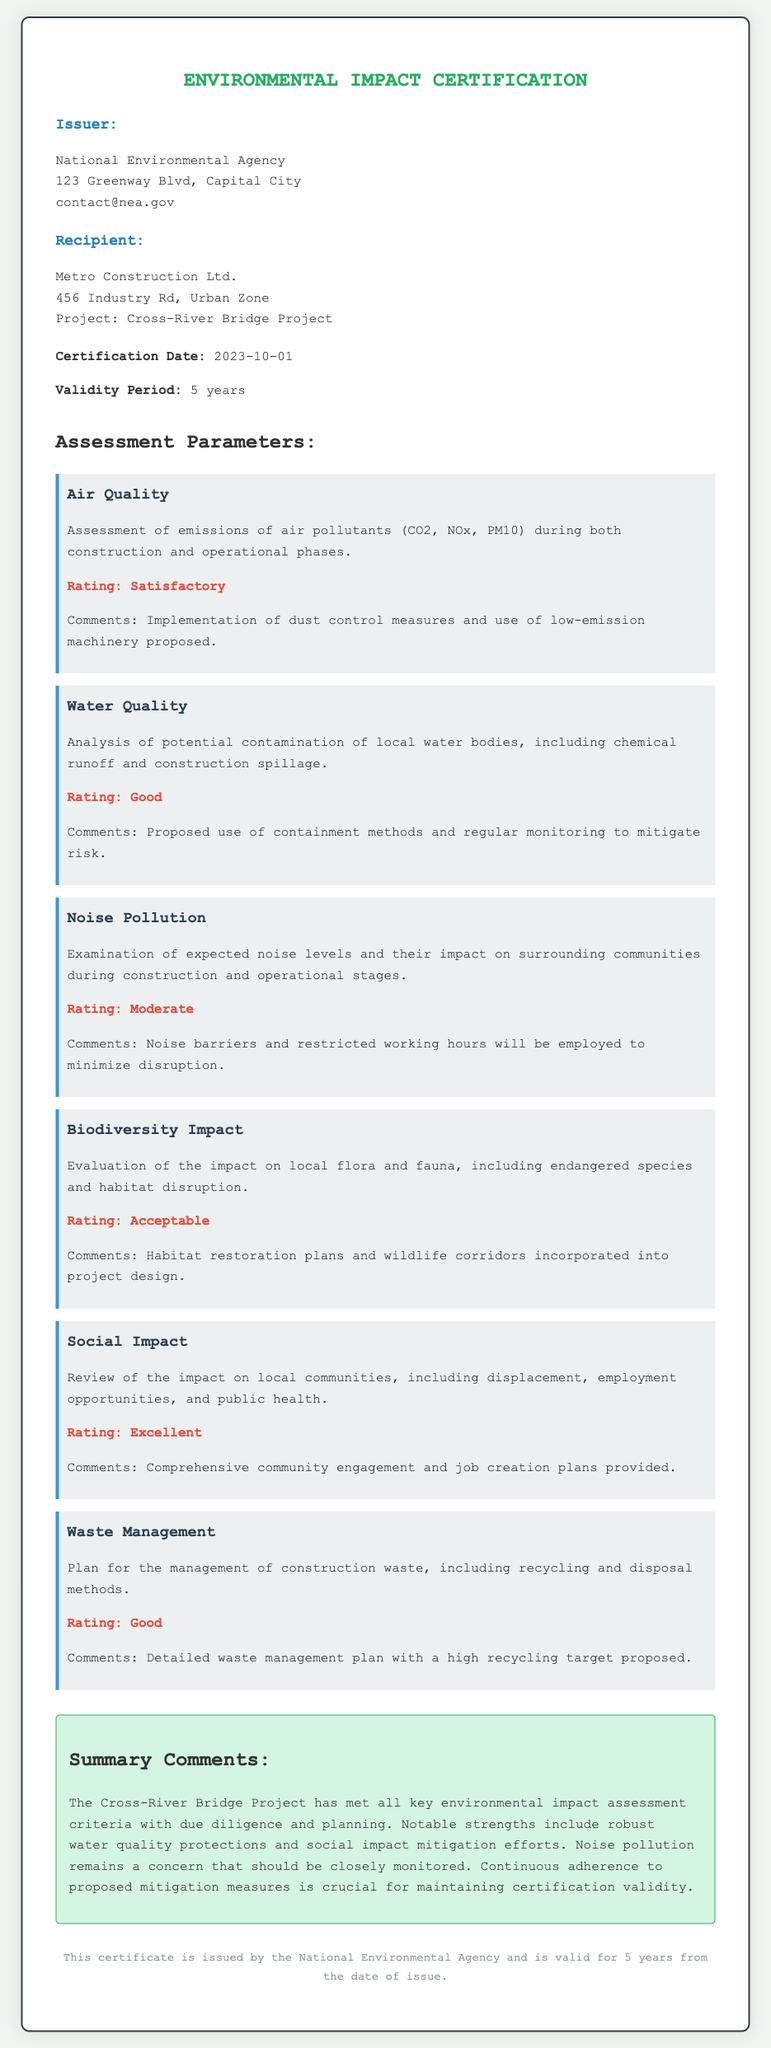What is the name of the issuer? The issuer of the certificate is identified in the document as the organization that is responsible for issuing the Environmental Impact Certification.
Answer: National Environmental Agency What is the certification date? The document specifies the date when the certification was officially issued.
Answer: 2023-10-01 How long is the validity period of the certificate? The validity period indicates how long the certificate remains effective as per the information provided.
Answer: 5 years What is the rating for air quality? This information reflects the assessment outcome regarding air quality impacts during the project's phases.
Answer: Satisfactory What measures are proposed to mitigate noise pollution? The document outlines specific actions taken to address noise concerns during construction and operation.
Answer: Noise barriers and restricted working hours Which parameter received an "Excellent" rating? An evaluation of social factors resulted in the highest rating, indicating strong positive impacts on communities.
Answer: Social Impact What comments were made regarding biodiversity impact? The comments are related to how the project is expected to affect local species and habitats, as mentioned in the assessment.
Answer: Habitat restoration plans and wildlife corridors incorporated into project design What was highlighted as a notable strength of the project? The summary comments at the end of the document emphasize specific achievements or effective practices of the project.
Answer: Robust water quality protections What is said about waste management in the certificate? The assessment reviews how the project plans to handle construction waste and recycling measures.
Answer: Detailed waste management plan with a high recycling target proposed What type of project is this certification for? The document refers to a specific construction initiative which is crucial for understanding the purpose of the certification.
Answer: Cross-River Bridge Project 